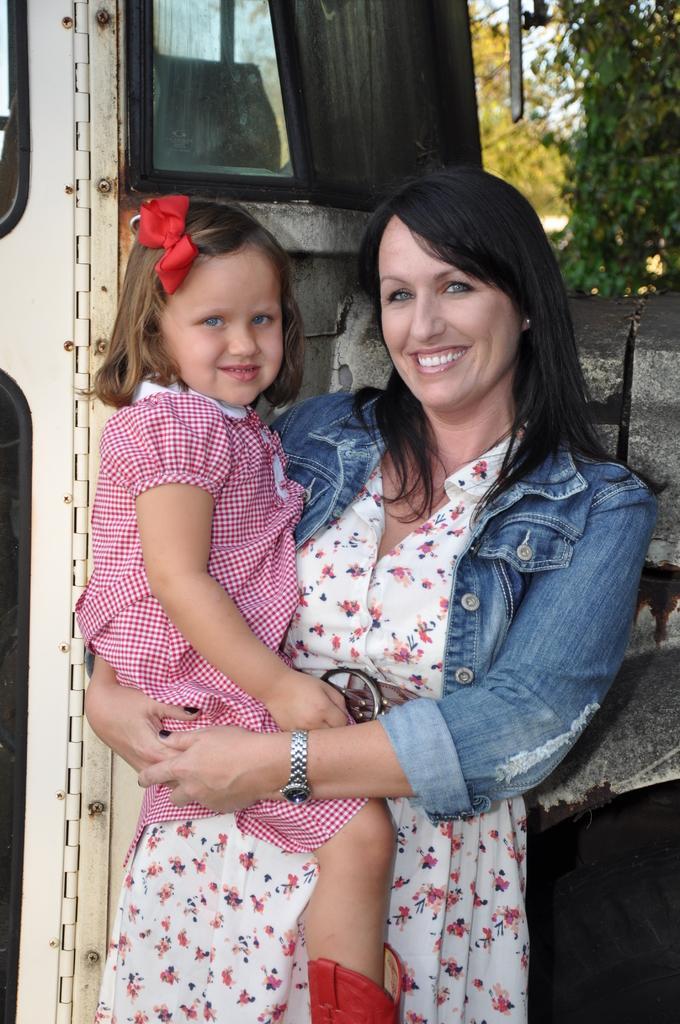Could you give a brief overview of what you see in this image? In this image I can see a woman is standing and I can also see smile on her face. I can see she is holding a girl. In the background I can see a vehicle type thing and few trees. 